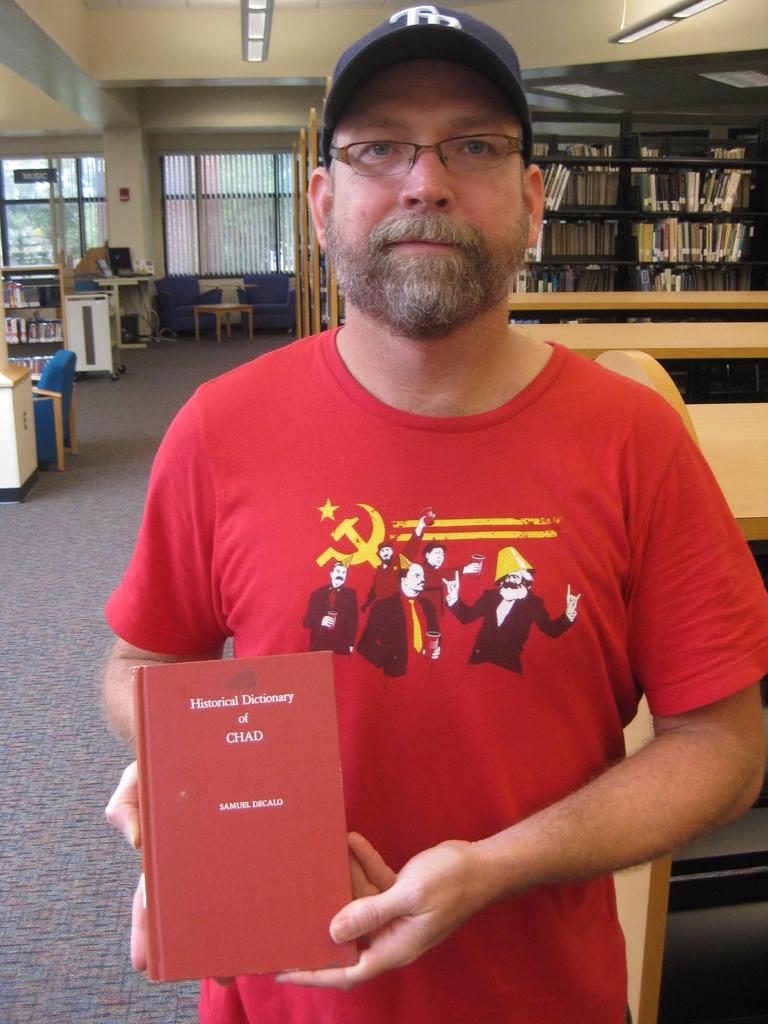Of what is this dictionary?
Provide a succinct answer. Chad. Who wrote this book?
Make the answer very short. Samuel decalo. 